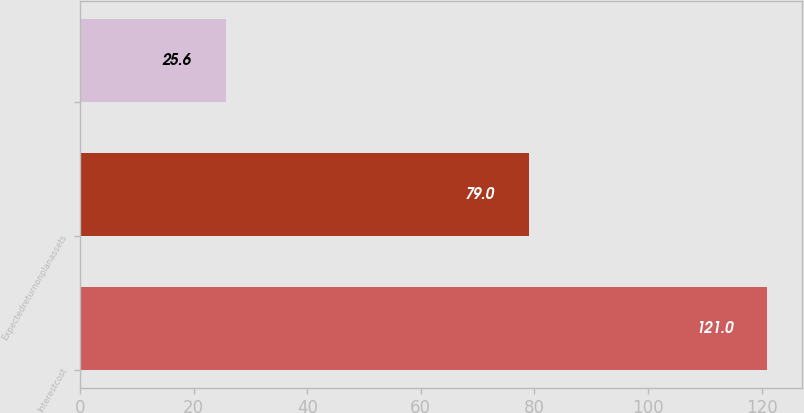<chart> <loc_0><loc_0><loc_500><loc_500><bar_chart><fcel>Interestcost<fcel>Expectedreturnonplanassets<fcel>Unnamed: 2<nl><fcel>121<fcel>79<fcel>25.6<nl></chart> 